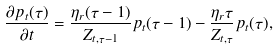<formula> <loc_0><loc_0><loc_500><loc_500>\frac { \partial p _ { t } ( \tau ) } { \partial t } = \frac { \eta _ { r } ( \tau - 1 ) } { Z _ { t , \tau - 1 } } p _ { t } ( \tau - 1 ) - \frac { \eta _ { r } \tau } { Z _ { t , \tau } } p _ { t } ( \tau ) ,</formula> 